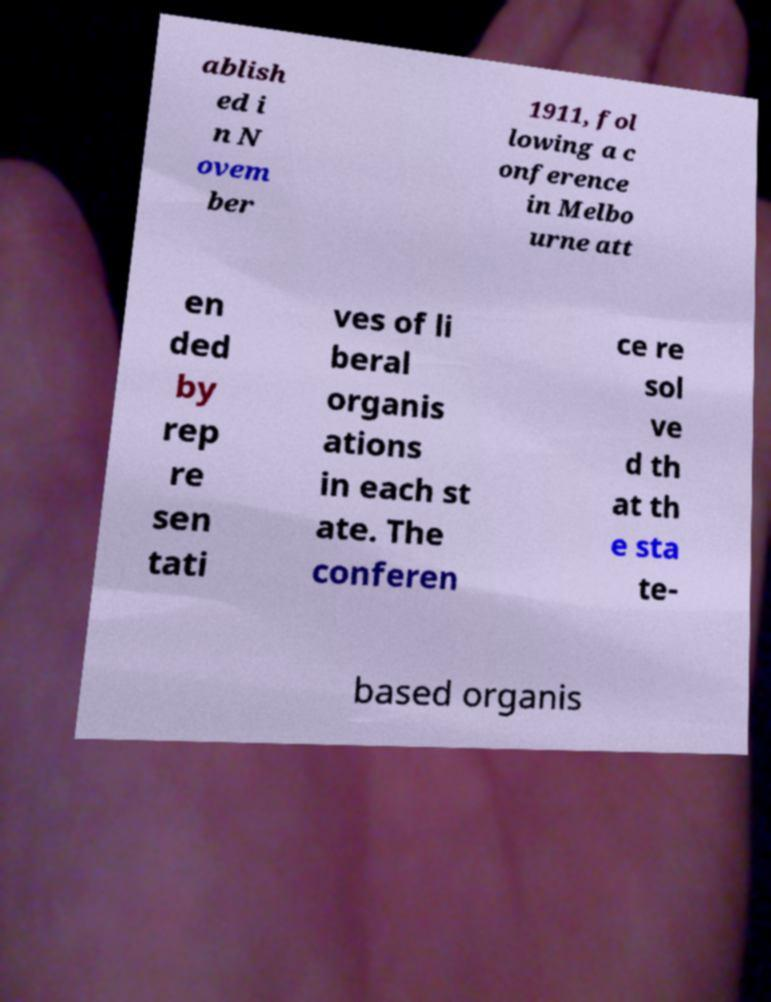For documentation purposes, I need the text within this image transcribed. Could you provide that? ablish ed i n N ovem ber 1911, fol lowing a c onference in Melbo urne att en ded by rep re sen tati ves of li beral organis ations in each st ate. The conferen ce re sol ve d th at th e sta te- based organis 